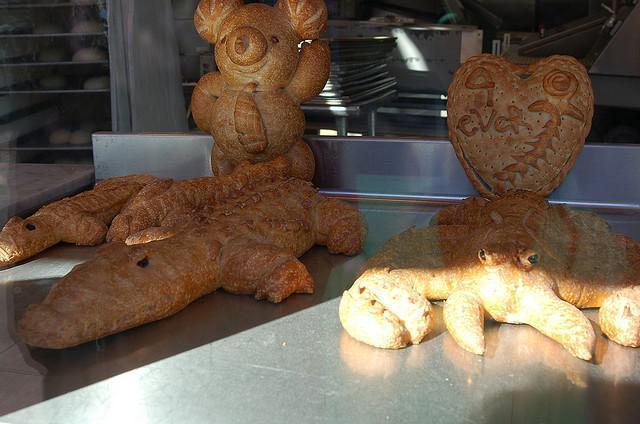How many people are surfing?
Give a very brief answer. 0. 